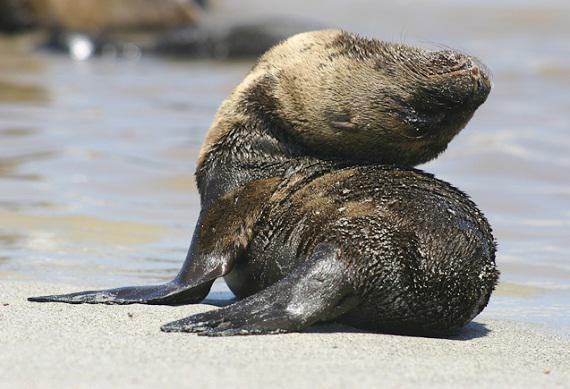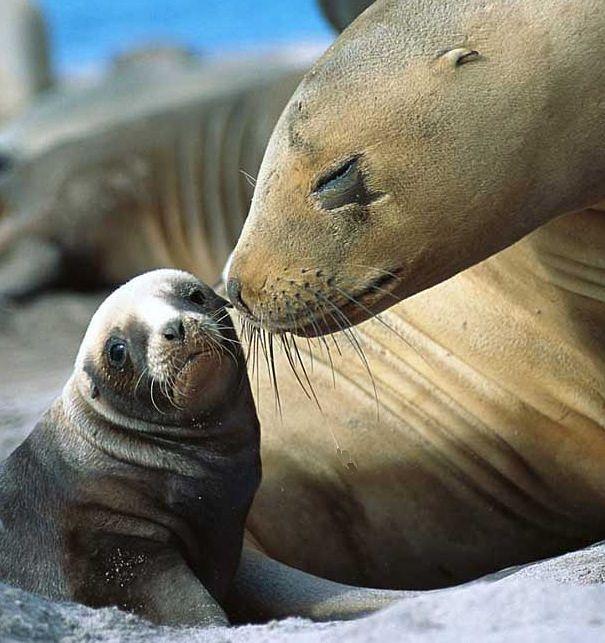The first image is the image on the left, the second image is the image on the right. For the images shown, is this caption "An image shows an adult seal on the right with its neck turned to point its nose down toward a baby seal." true? Answer yes or no. Yes. The first image is the image on the left, the second image is the image on the right. Analyze the images presented: Is the assertion "The right image contains an adult seal with a child seal." valid? Answer yes or no. Yes. 